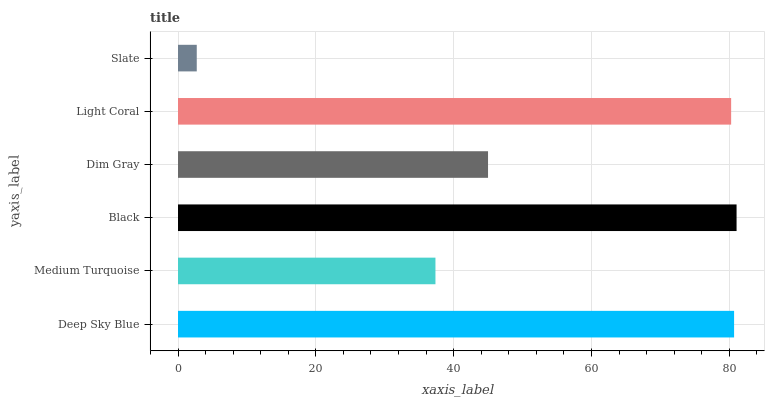Is Slate the minimum?
Answer yes or no. Yes. Is Black the maximum?
Answer yes or no. Yes. Is Medium Turquoise the minimum?
Answer yes or no. No. Is Medium Turquoise the maximum?
Answer yes or no. No. Is Deep Sky Blue greater than Medium Turquoise?
Answer yes or no. Yes. Is Medium Turquoise less than Deep Sky Blue?
Answer yes or no. Yes. Is Medium Turquoise greater than Deep Sky Blue?
Answer yes or no. No. Is Deep Sky Blue less than Medium Turquoise?
Answer yes or no. No. Is Light Coral the high median?
Answer yes or no. Yes. Is Dim Gray the low median?
Answer yes or no. Yes. Is Medium Turquoise the high median?
Answer yes or no. No. Is Light Coral the low median?
Answer yes or no. No. 